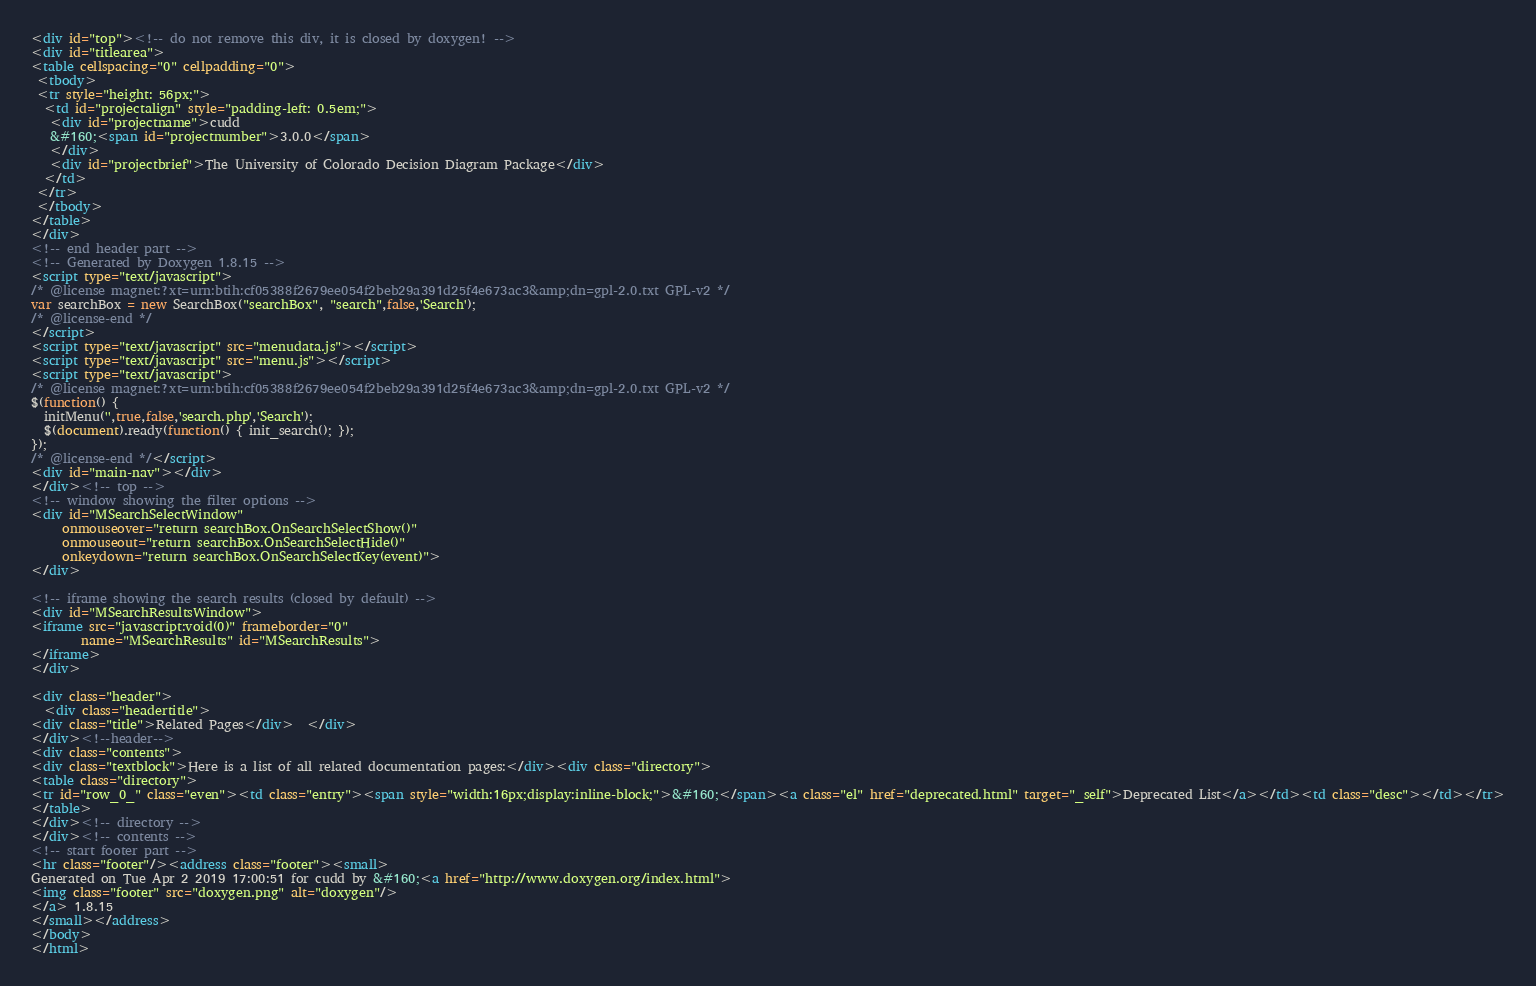Convert code to text. <code><loc_0><loc_0><loc_500><loc_500><_HTML_><div id="top"><!-- do not remove this div, it is closed by doxygen! -->
<div id="titlearea">
<table cellspacing="0" cellpadding="0">
 <tbody>
 <tr style="height: 56px;">
  <td id="projectalign" style="padding-left: 0.5em;">
   <div id="projectname">cudd
   &#160;<span id="projectnumber">3.0.0</span>
   </div>
   <div id="projectbrief">The University of Colorado Decision Diagram Package</div>
  </td>
 </tr>
 </tbody>
</table>
</div>
<!-- end header part -->
<!-- Generated by Doxygen 1.8.15 -->
<script type="text/javascript">
/* @license magnet:?xt=urn:btih:cf05388f2679ee054f2beb29a391d25f4e673ac3&amp;dn=gpl-2.0.txt GPL-v2 */
var searchBox = new SearchBox("searchBox", "search",false,'Search');
/* @license-end */
</script>
<script type="text/javascript" src="menudata.js"></script>
<script type="text/javascript" src="menu.js"></script>
<script type="text/javascript">
/* @license magnet:?xt=urn:btih:cf05388f2679ee054f2beb29a391d25f4e673ac3&amp;dn=gpl-2.0.txt GPL-v2 */
$(function() {
  initMenu('',true,false,'search.php','Search');
  $(document).ready(function() { init_search(); });
});
/* @license-end */</script>
<div id="main-nav"></div>
</div><!-- top -->
<!-- window showing the filter options -->
<div id="MSearchSelectWindow"
     onmouseover="return searchBox.OnSearchSelectShow()"
     onmouseout="return searchBox.OnSearchSelectHide()"
     onkeydown="return searchBox.OnSearchSelectKey(event)">
</div>

<!-- iframe showing the search results (closed by default) -->
<div id="MSearchResultsWindow">
<iframe src="javascript:void(0)" frameborder="0" 
        name="MSearchResults" id="MSearchResults">
</iframe>
</div>

<div class="header">
  <div class="headertitle">
<div class="title">Related Pages</div>  </div>
</div><!--header-->
<div class="contents">
<div class="textblock">Here is a list of all related documentation pages:</div><div class="directory">
<table class="directory">
<tr id="row_0_" class="even"><td class="entry"><span style="width:16px;display:inline-block;">&#160;</span><a class="el" href="deprecated.html" target="_self">Deprecated List</a></td><td class="desc"></td></tr>
</table>
</div><!-- directory -->
</div><!-- contents -->
<!-- start footer part -->
<hr class="footer"/><address class="footer"><small>
Generated on Tue Apr 2 2019 17:00:51 for cudd by &#160;<a href="http://www.doxygen.org/index.html">
<img class="footer" src="doxygen.png" alt="doxygen"/>
</a> 1.8.15
</small></address>
</body>
</html>
</code> 